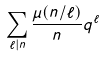Convert formula to latex. <formula><loc_0><loc_0><loc_500><loc_500>\sum _ { \ell | n } \frac { \mu ( n / \ell ) } { n } q ^ { \ell }</formula> 